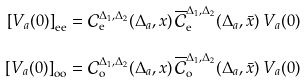<formula> <loc_0><loc_0><loc_500><loc_500>\left [ V _ { a } ( 0 ) \right ] _ { \text {ee} } & = \mathcal { C } _ { \text {e} } ^ { \Delta _ { 1 } , \Delta _ { 2 } } ( \Delta _ { a } , x ) \, \overline { \mathcal { C } } _ { \text {e} } ^ { \Delta _ { 1 } , \Delta _ { 2 } } ( \Delta _ { a } , \bar { x } ) \, V _ { a } ( 0 ) \\ \left [ V _ { a } ( 0 ) \right ] _ { \text {oo} } & = \mathcal { C } _ { \text {o} } ^ { \Delta _ { 1 } , \Delta _ { 2 } } ( \Delta _ { a } , x ) \, \overline { \mathcal { C } } _ { \text {o} } ^ { \Delta _ { 1 } , \Delta _ { 2 } } ( \Delta _ { a } , \bar { x } ) \, V _ { a } ( 0 )</formula> 